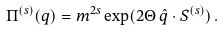Convert formula to latex. <formula><loc_0><loc_0><loc_500><loc_500>\Pi ^ { ( s ) } ( q ) = m ^ { 2 s } \exp ( 2 \Theta \, \hat { q } \cdot { S } ^ { ( s ) } ) \, .</formula> 